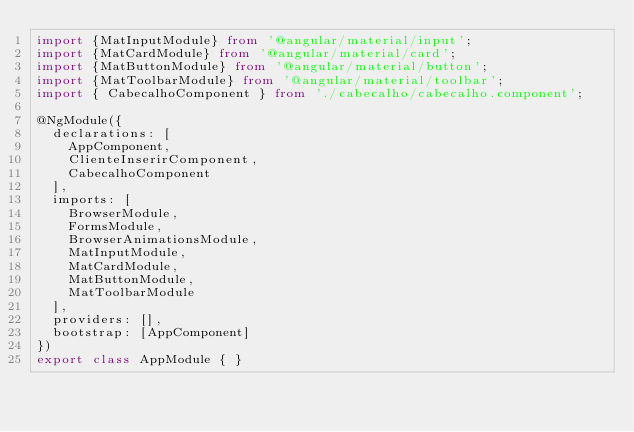Convert code to text. <code><loc_0><loc_0><loc_500><loc_500><_TypeScript_>import {MatInputModule} from '@angular/material/input'; 
import {MatCardModule} from '@angular/material/card';
import {MatButtonModule} from '@angular/material/button';
import {MatToolbarModule} from '@angular/material/toolbar';
import { CabecalhoComponent } from './cabecalho/cabecalho.component';

@NgModule({
  declarations: [
    AppComponent,
    ClienteInserirComponent,
    CabecalhoComponent
  ],
  imports: [
    BrowserModule,
    FormsModule,
    BrowserAnimationsModule,
    MatInputModule,
    MatCardModule,
    MatButtonModule,
    MatToolbarModule
  ],
  providers: [],
  bootstrap: [AppComponent]
})
export class AppModule { }
</code> 